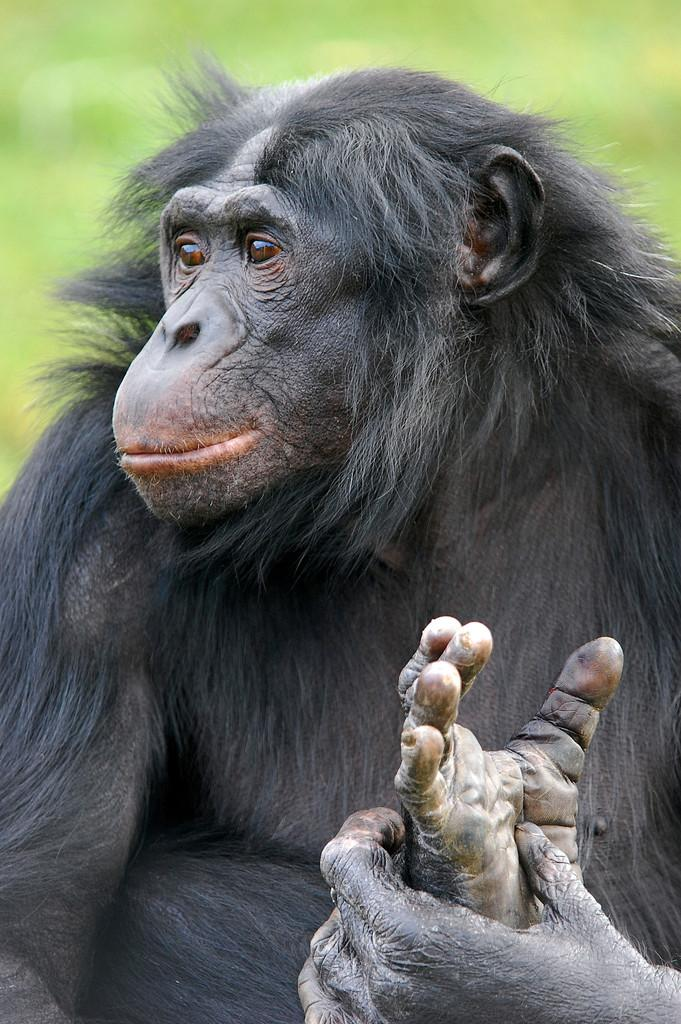What type of animal is in the image? There is a chimpanzee in the image. What color is the chimpanzee? The chimpanzee is black in color. What can be seen in the background of the image? The background of the image is green. What type of skirt is the chimpanzeepee wearing in the image? There is no skirt present in the image, as chimpanzees do not wear clothing. Can you tell me how many goldfish are swimming in the background of the image? There are no goldfish present in the image; the background is green. 